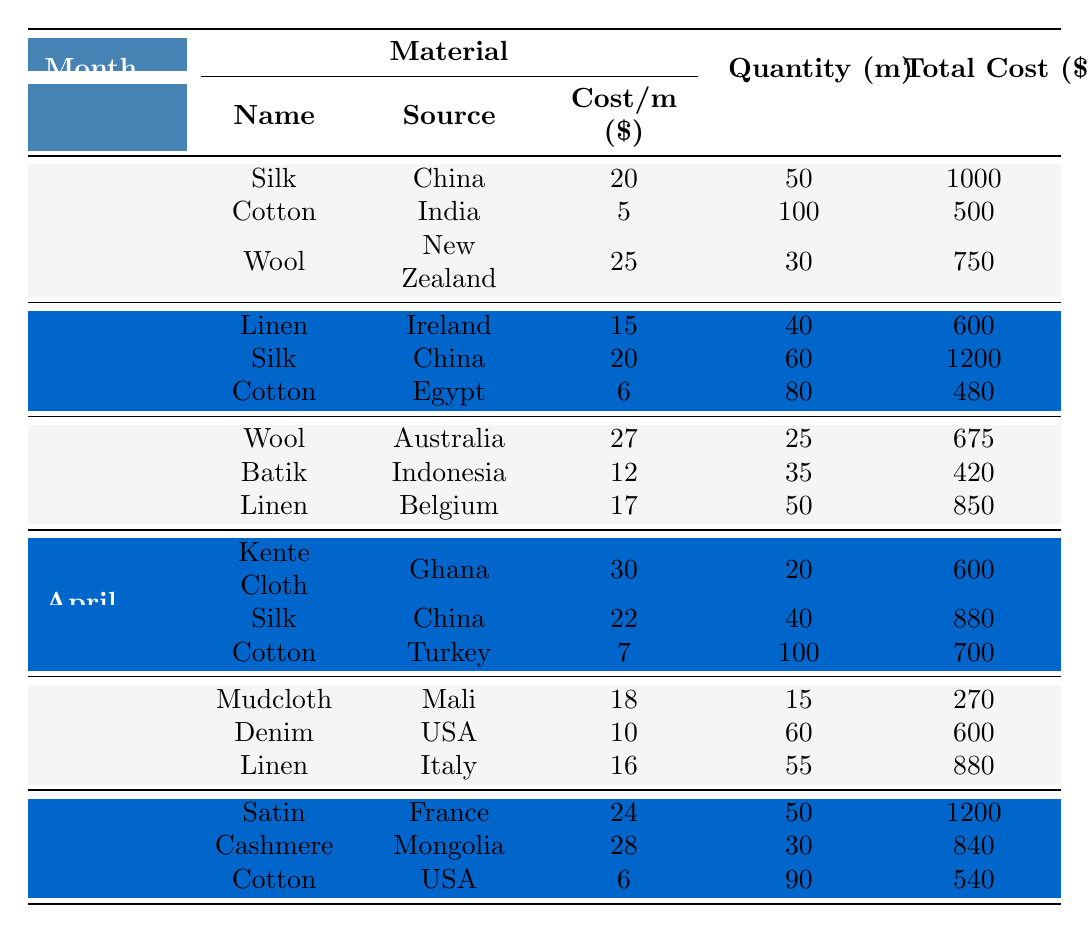What is the total cost of materials procured in January? To find the total cost of materials for January, we add the total costs for each material in that month: Silk (1000) + Cotton (500) + Wool (750) = 2250.
Answer: 2250 Which material had the highest cost per meter in February? In February, the materials and their costs per meter are: Linen at 15, Silk at 20, and Cotton at 6. Silk has the highest cost per meter at 20.
Answer: Silk How many meters of Cotton were procured across all months? To find the total meters of Cotton, we sum the quantity of Cotton from each month: January (100) + February (80) + April (100) + June (90) = 370.
Answer: 370 What is the average total cost of materials per month? The total costs for each month are: January (2250), February (2280), March (1965), April (2180), May (1750), June (2580). Sum these (2250 + 2280 + 1965 + 2180 + 1750 + 2580 = 13005) and divide by the number of months (6): 13005/6 = 2167.5.
Answer: 2167.5 Is it true that Kente Cloth was the only material sourced from Ghana? Looking at the table, Kente Cloth is listed with Ghana as the source, and no other material is listed from Ghana, confirming that it's true that Kente Cloth is the only one.
Answer: Yes Which month had the least total cost for materials? The total costs for each month are: January (2250), February (2280), March (1965), April (2180), May (1750), June (2580). The least total cost is in May, which is 1750.
Answer: May What is the total quantity of Wool procured in March and April? In March, Wool quantity is 25 meters, and in April there is no Wool listed. Therefore, we only consider March's quantity: 25 meters (March) + 0 (April) = 25 meters in total.
Answer: 25 meters Which month had the highest quantity of Linen procured? The quantities of Linen are: January (0), February (40), March (50), April (0), May (55), June (0). The highest quantity is in May, with 55 meters.
Answer: May What is the sum of the total costs of materials that were sourced from China? The total costs from China include: Silk in January (1000), Silk in February (1200), and Silk in April (880), which totals 1000 + 1200 + 880 = 3080.
Answer: 3080 